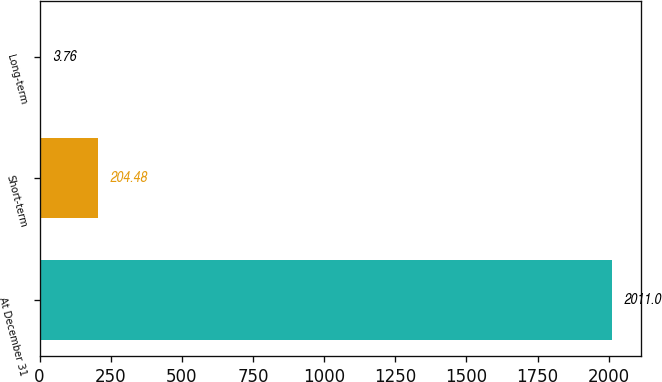Convert chart to OTSL. <chart><loc_0><loc_0><loc_500><loc_500><bar_chart><fcel>At December 31<fcel>Short-term<fcel>Long-term<nl><fcel>2011<fcel>204.48<fcel>3.76<nl></chart> 